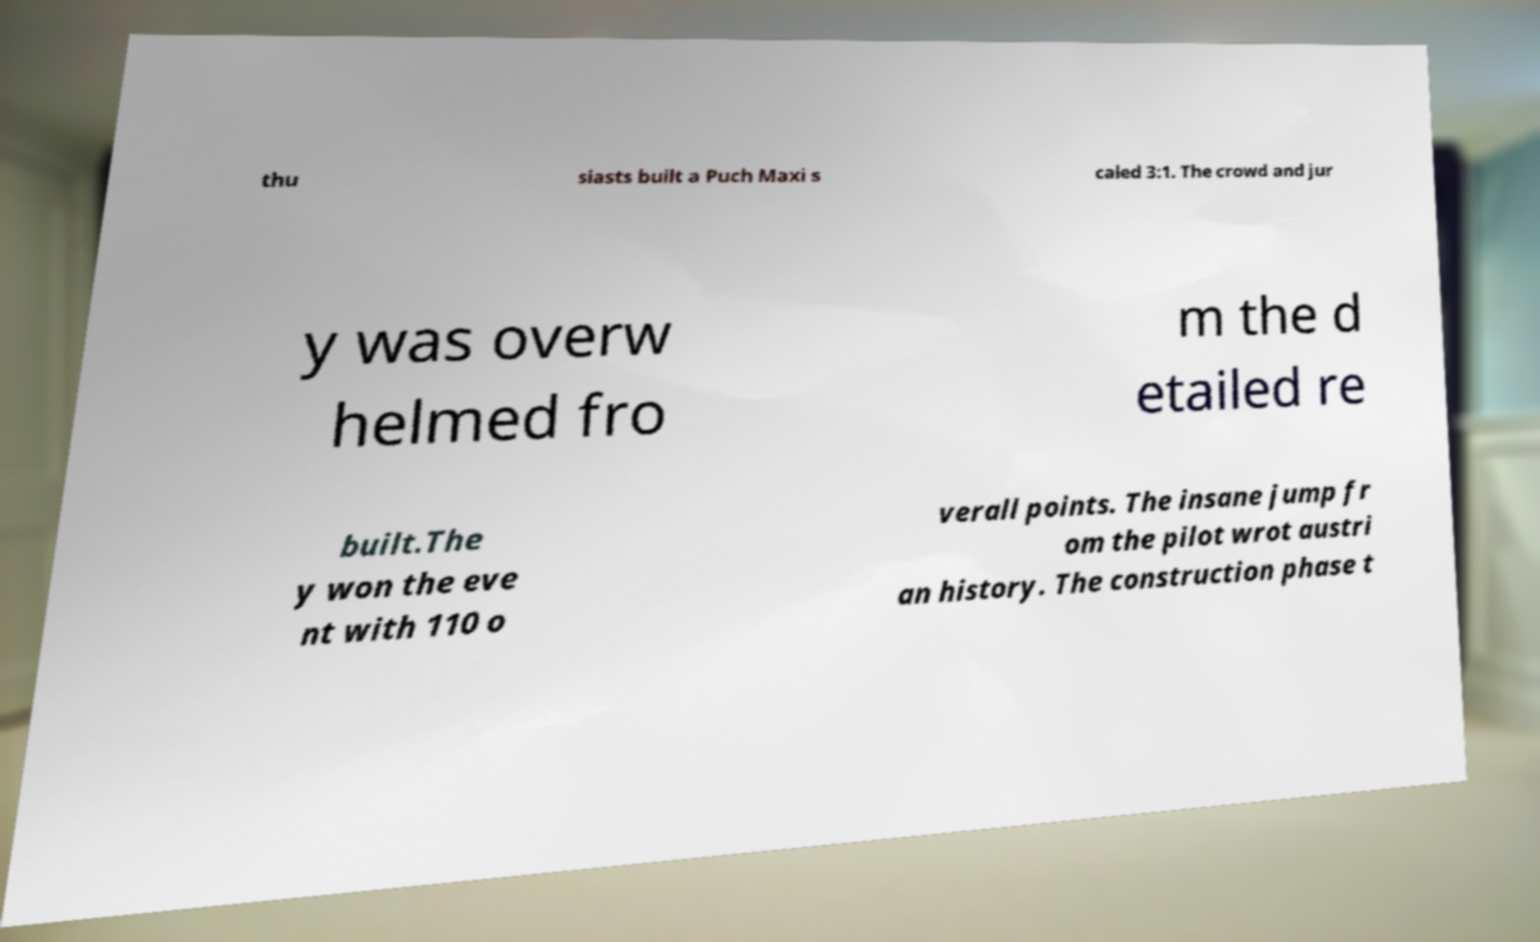For documentation purposes, I need the text within this image transcribed. Could you provide that? thu siasts built a Puch Maxi s caled 3:1. The crowd and jur y was overw helmed fro m the d etailed re built.The y won the eve nt with 110 o verall points. The insane jump fr om the pilot wrot austri an history. The construction phase t 